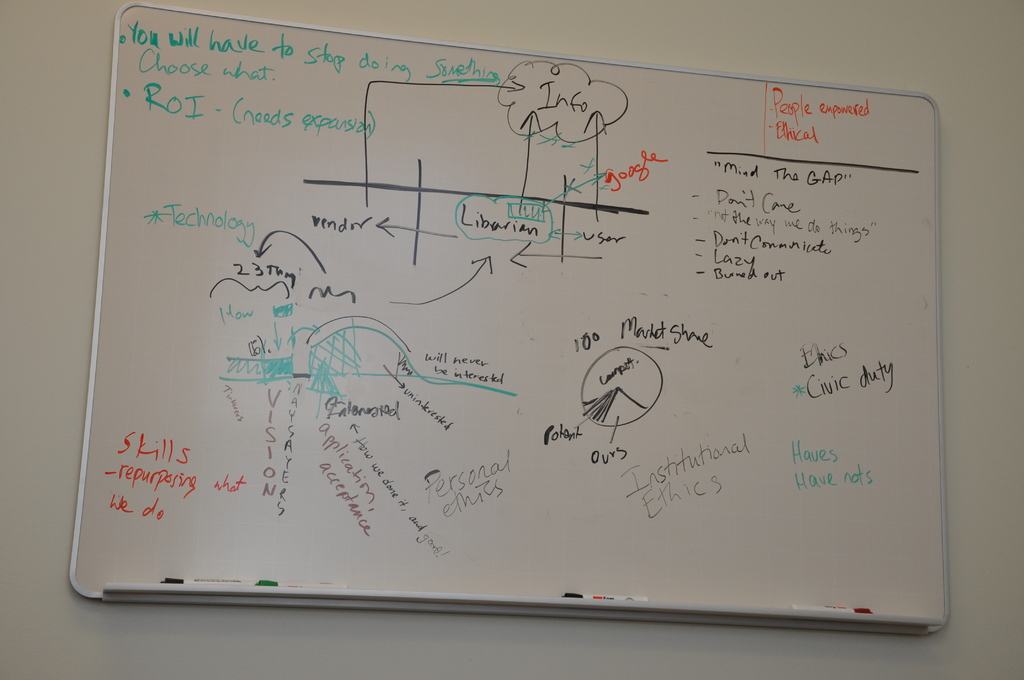What's the significance of the bridge and the labels 'Librarian' and 'User' depicted in the drawing? The bridge drawing represents the need to connect or facilitate better communication between different roles or departments, as indicated by the labels 'Librarian' and 'User'. This metaphor suggests aiming for improved interactions and service delivery, potentially bridging the gap in information access and utilization between service providers (Librarian) and recipients (User). What might 'Personal Ethics' versus 'Institutional Ethics' imply in this context? In this context, the distinction between 'Personal Ethics' and 'Institutional Ethics' likely points to a discussion about aligning individual staff behavior with the broader ethical standards of the organization. This could involve addressing how personal values integrate with formal codes of conduct and the implications for decision-making and responsibility within the workplace. 